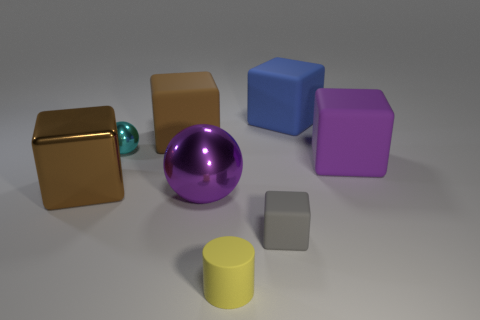What size is the shiny sphere in front of the large brown metallic block?
Offer a very short reply. Large. Is there a large brown object that has the same material as the cylinder?
Offer a very short reply. Yes. Do the big matte thing that is left of the small matte cylinder and the rubber cylinder have the same color?
Your response must be concise. No. Are there an equal number of yellow rubber objects in front of the yellow rubber object and blue cylinders?
Ensure brevity in your answer.  Yes. Are there any large metal balls that have the same color as the small metal object?
Offer a very short reply. No. Is the size of the purple matte block the same as the blue rubber cube?
Give a very brief answer. Yes. There is a blue rubber cube behind the metallic thing behind the large brown shiny block; what size is it?
Your answer should be compact. Large. There is a cube that is on the right side of the big shiny cube and on the left side of the tiny cylinder; how big is it?
Your answer should be very brief. Large. How many purple spheres have the same size as the purple rubber object?
Give a very brief answer. 1. How many rubber objects are either large brown blocks or big purple blocks?
Your response must be concise. 2. 